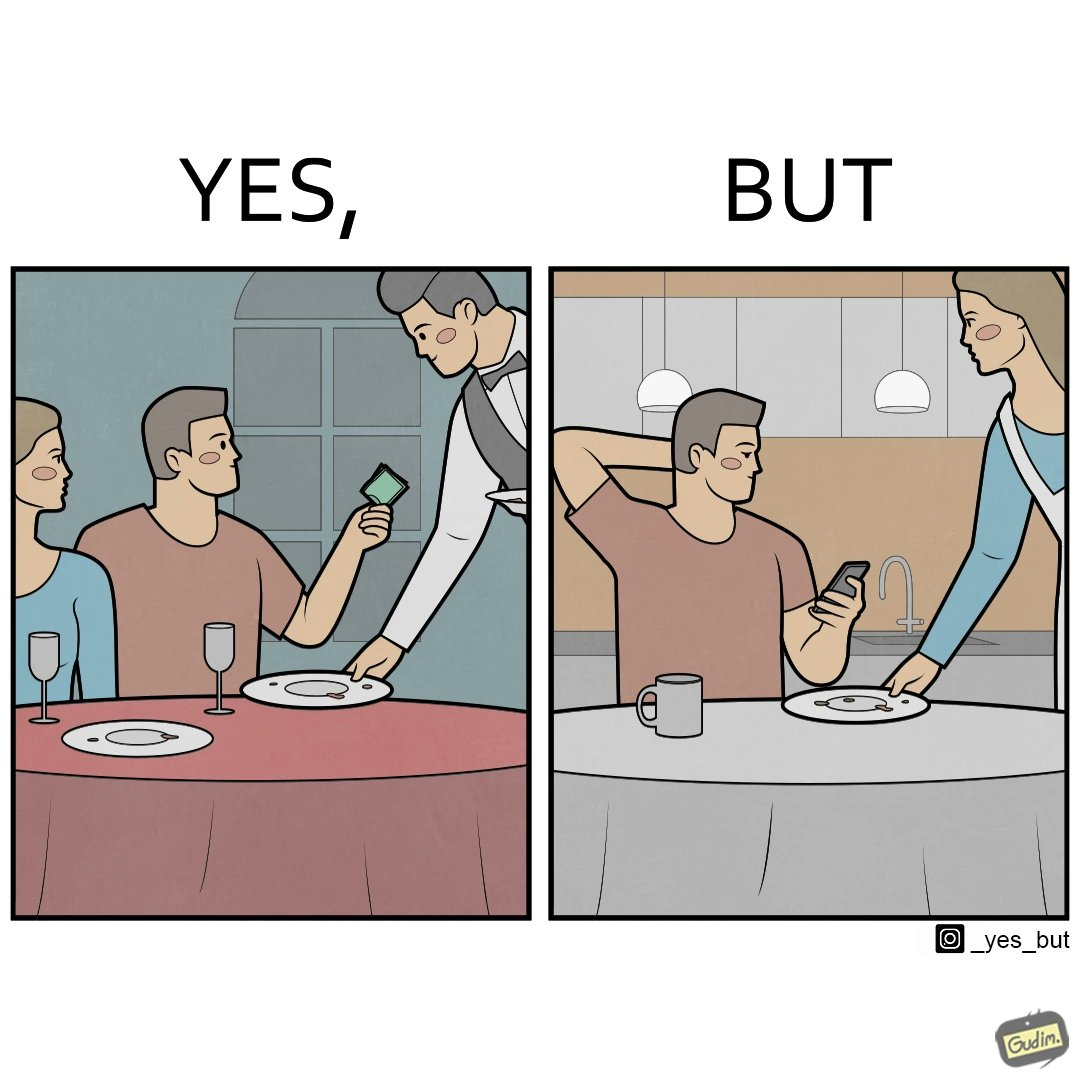Describe the satirical element in this image. The image is ironical, as a man tips the waiter at a restaurant for the meal, but seems to not even acknowledge when his wife has made the meal for him at home. 